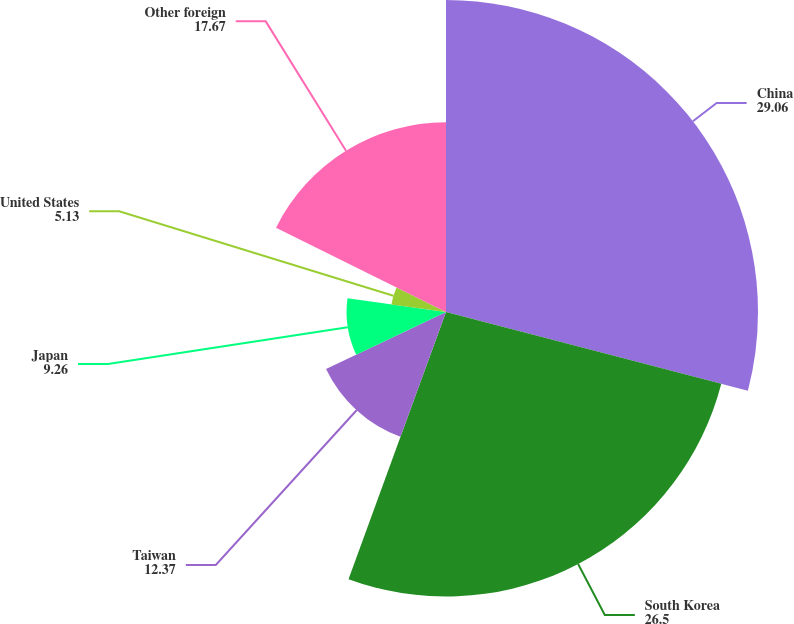<chart> <loc_0><loc_0><loc_500><loc_500><pie_chart><fcel>China<fcel>South Korea<fcel>Taiwan<fcel>Japan<fcel>United States<fcel>Other foreign<nl><fcel>29.06%<fcel>26.5%<fcel>12.37%<fcel>9.26%<fcel>5.13%<fcel>17.67%<nl></chart> 